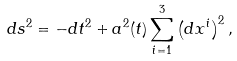<formula> <loc_0><loc_0><loc_500><loc_500>d s ^ { 2 } = - d t ^ { 2 } + a ^ { 2 } ( t ) \sum _ { i = 1 } ^ { 3 } \left ( d x ^ { i } \right ) ^ { 2 } ,</formula> 